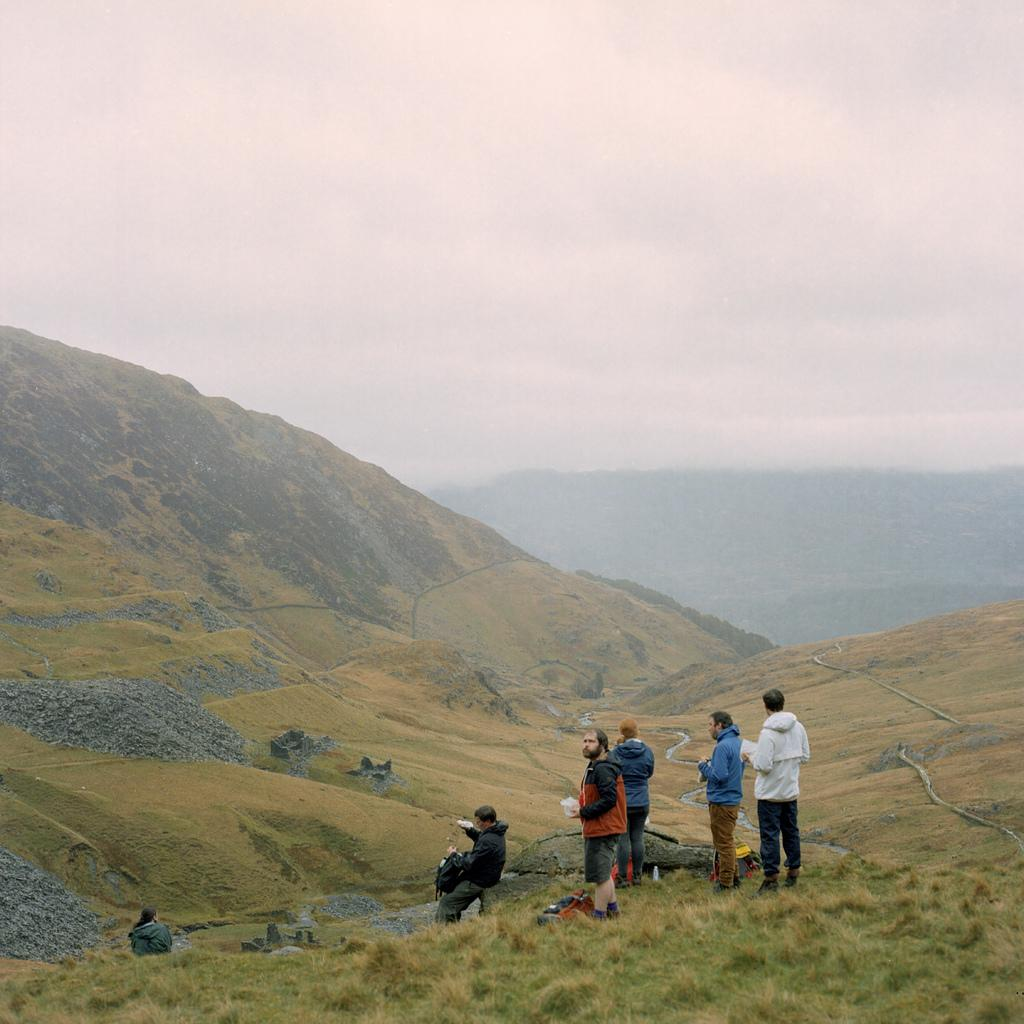How many people are in the image? There is a group of persons in the image. What is the surface the persons are standing on? The persons are standing on the grass. What can be seen in the distance behind the group of persons? There are hills visible in the background of the image. What else is visible in the background of the image? The sky is visible in the background of the image. What type of station is visible in the image? There is no station present in the image. Can you describe the structure of the elbow in the image? There is no elbow present in the image. 